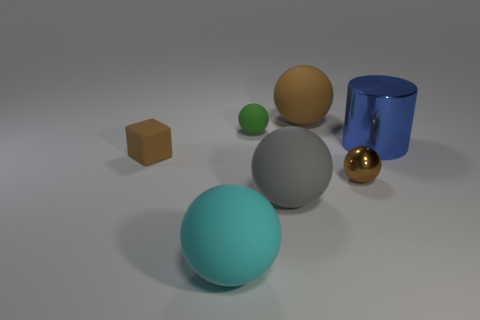Subtract all small brown spheres. How many spheres are left? 4 Subtract all red cylinders. Subtract all blue balls. How many cylinders are left? 1 Add 2 tiny brown spheres. How many objects exist? 9 Subtract all cylinders. How many objects are left? 6 Add 4 large cyan rubber balls. How many large cyan rubber balls are left? 5 Add 5 large cyan metal cubes. How many large cyan metal cubes exist? 5 Subtract 0 green cylinders. How many objects are left? 7 Subtract all large cyan matte things. Subtract all large matte balls. How many objects are left? 3 